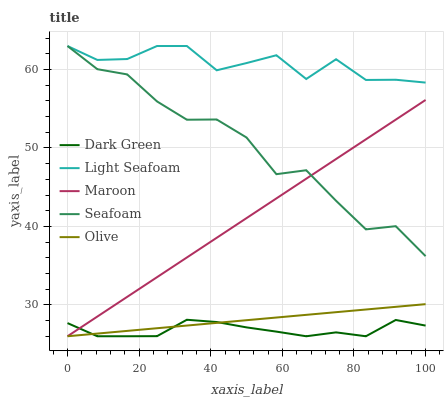Does Dark Green have the minimum area under the curve?
Answer yes or no. Yes. Does Light Seafoam have the maximum area under the curve?
Answer yes or no. Yes. Does Seafoam have the minimum area under the curve?
Answer yes or no. No. Does Seafoam have the maximum area under the curve?
Answer yes or no. No. Is Olive the smoothest?
Answer yes or no. Yes. Is Seafoam the roughest?
Answer yes or no. Yes. Is Light Seafoam the smoothest?
Answer yes or no. No. Is Light Seafoam the roughest?
Answer yes or no. No. Does Seafoam have the lowest value?
Answer yes or no. No. Does Seafoam have the highest value?
Answer yes or no. Yes. Does Maroon have the highest value?
Answer yes or no. No. Is Dark Green less than Light Seafoam?
Answer yes or no. Yes. Is Light Seafoam greater than Maroon?
Answer yes or no. Yes. Does Maroon intersect Seafoam?
Answer yes or no. Yes. Is Maroon less than Seafoam?
Answer yes or no. No. Is Maroon greater than Seafoam?
Answer yes or no. No. Does Dark Green intersect Light Seafoam?
Answer yes or no. No. 